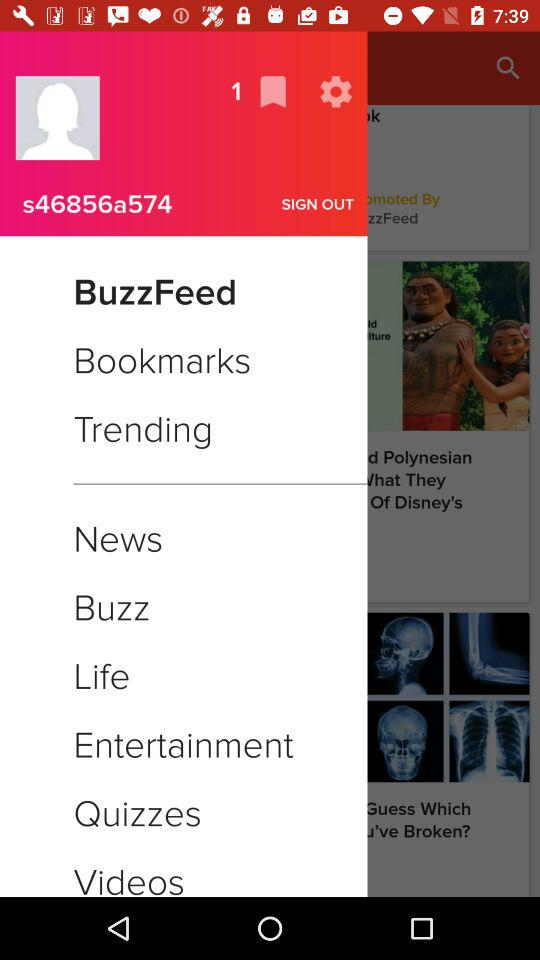What is the highlighted option? The highlighted option is BuzzFeed. 